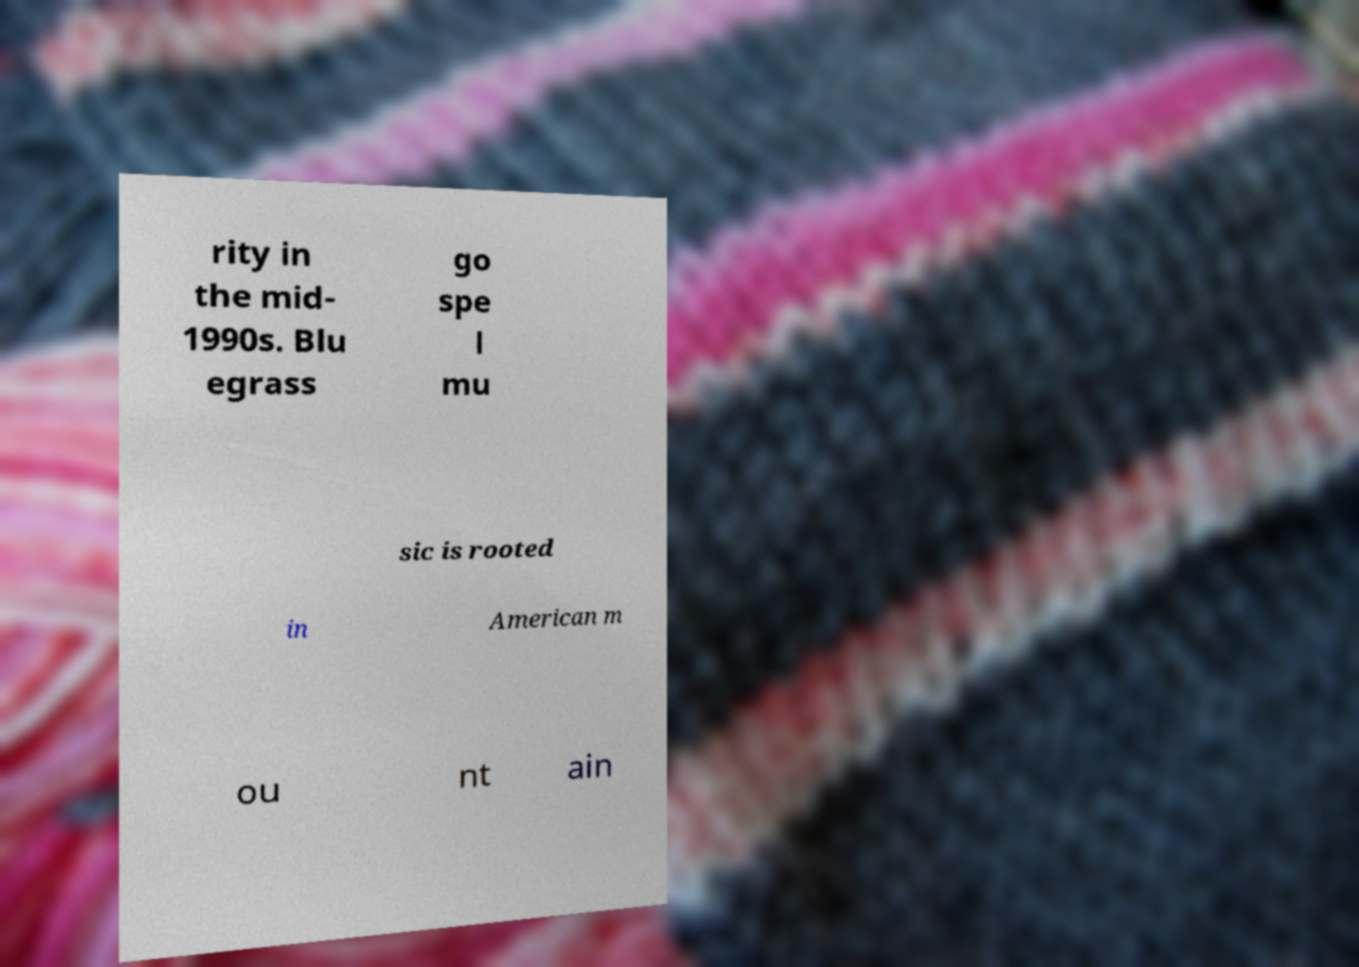What messages or text are displayed in this image? I need them in a readable, typed format. rity in the mid- 1990s. Blu egrass go spe l mu sic is rooted in American m ou nt ain 